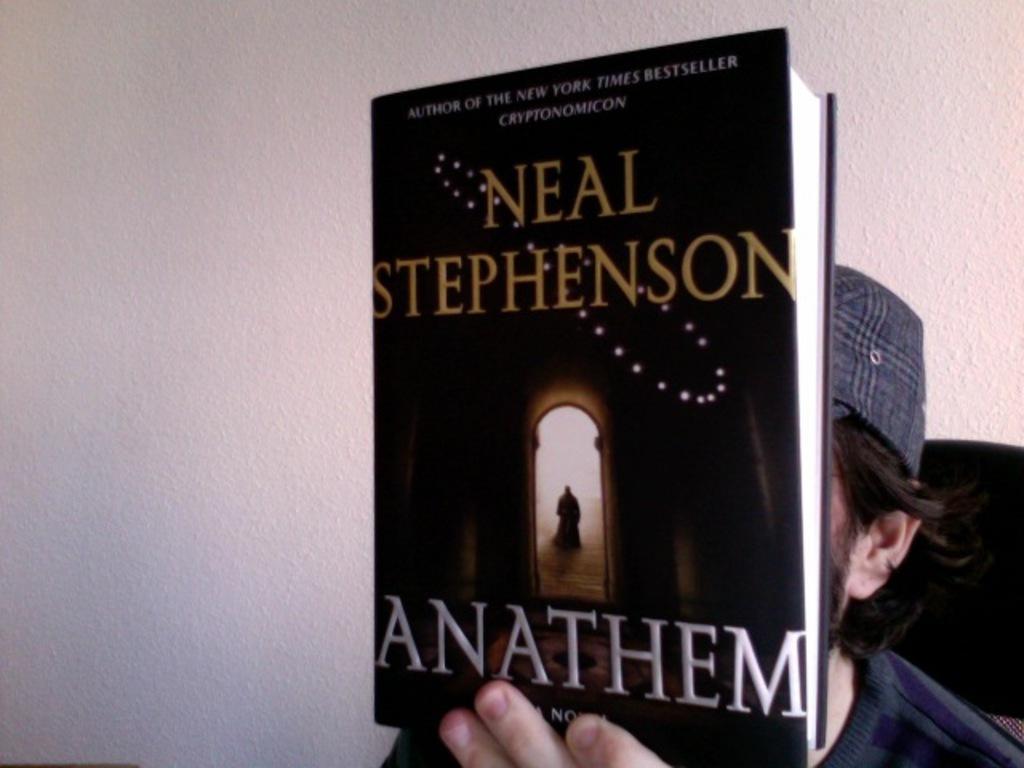Describe this image in one or two sentences. In this image we can see a man sitting holding a book. We can also see some text on it. On the backside we can see a wall. 